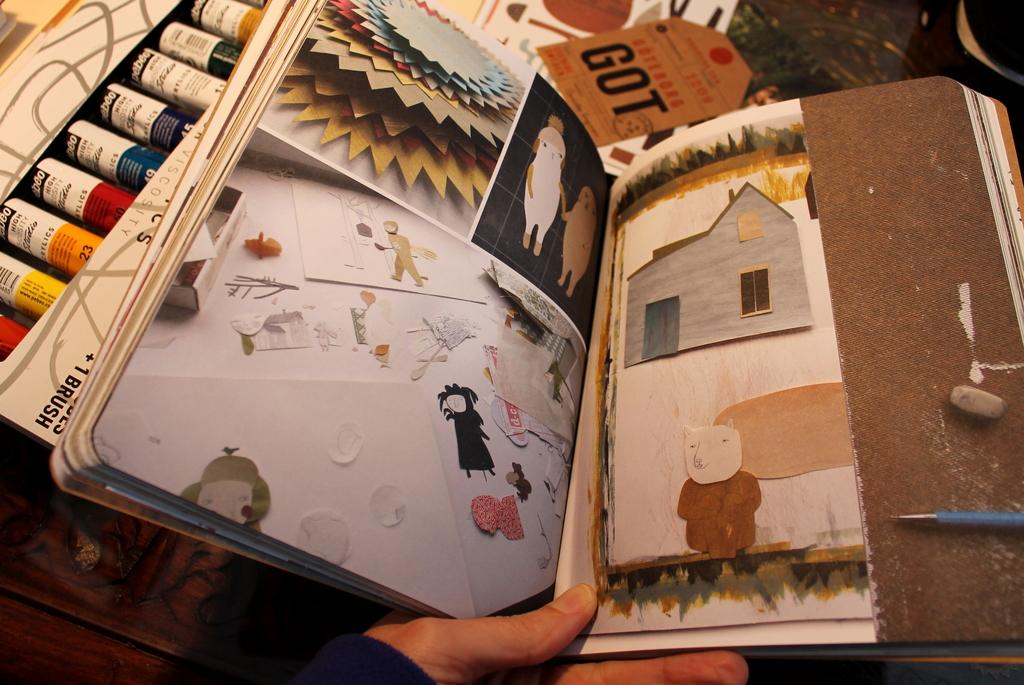<image>
Present a compact description of the photo's key features. An orange tag has the word got on it in large, black letters. 